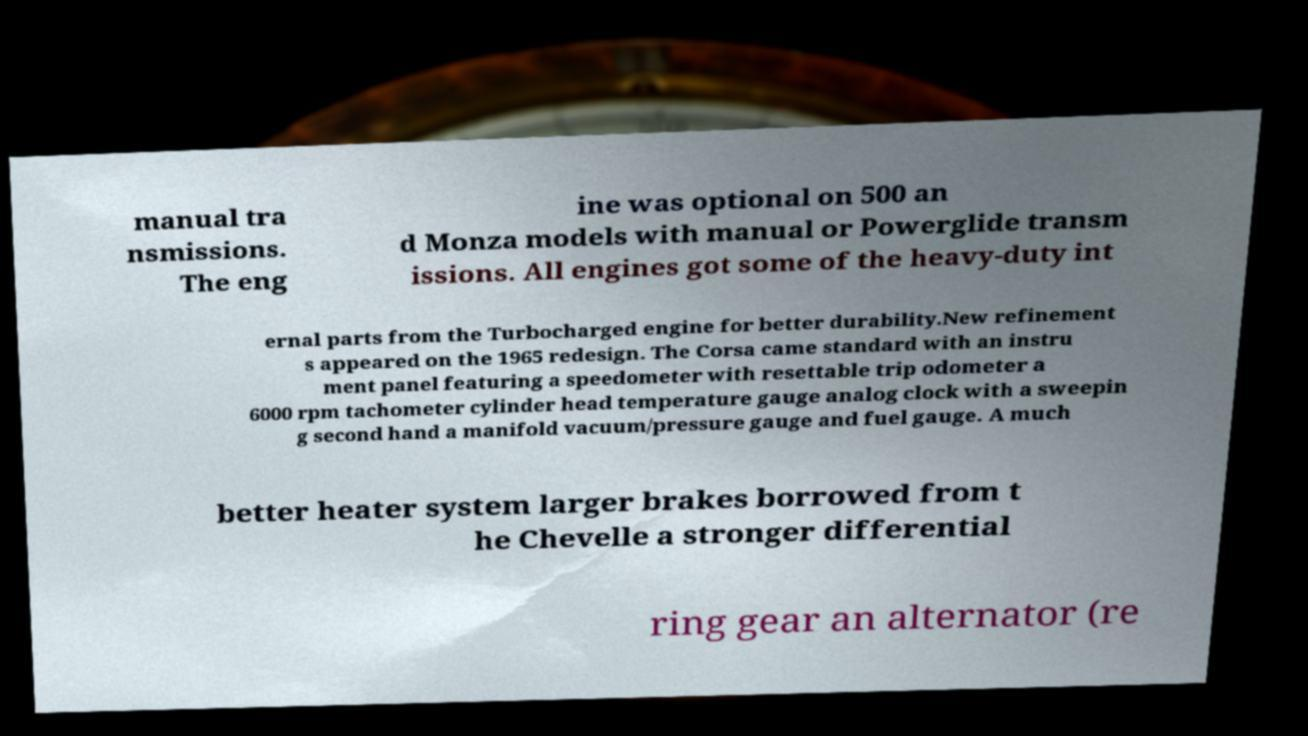Could you assist in decoding the text presented in this image and type it out clearly? manual tra nsmissions. The eng ine was optional on 500 an d Monza models with manual or Powerglide transm issions. All engines got some of the heavy-duty int ernal parts from the Turbocharged engine for better durability.New refinement s appeared on the 1965 redesign. The Corsa came standard with an instru ment panel featuring a speedometer with resettable trip odometer a 6000 rpm tachometer cylinder head temperature gauge analog clock with a sweepin g second hand a manifold vacuum/pressure gauge and fuel gauge. A much better heater system larger brakes borrowed from t he Chevelle a stronger differential ring gear an alternator (re 